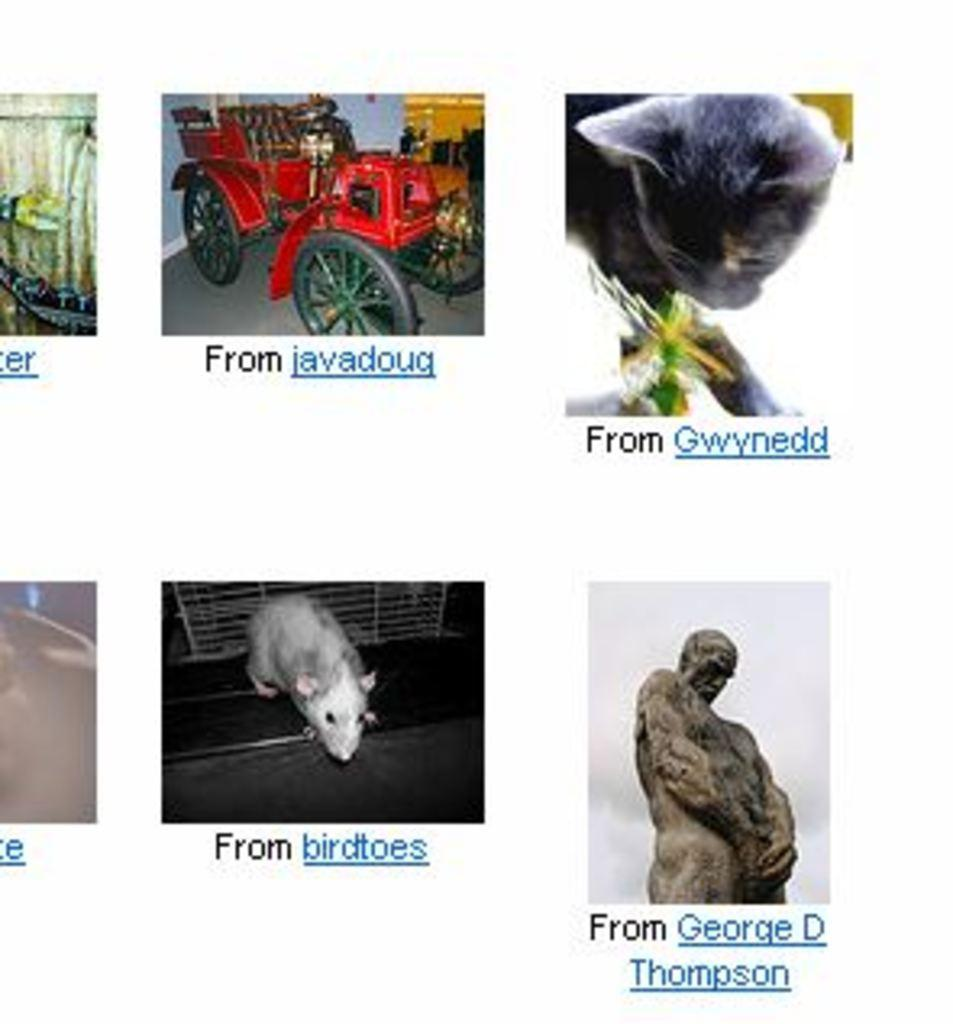What is displayed on the screen in the image? There are images and text on the screen in the image. What color is the background of the screen? The background of the screen is white. How many umbrellas are shown in the images on the screen? There is no information about umbrellas in the image, as it only mentions images and text on the screen. 